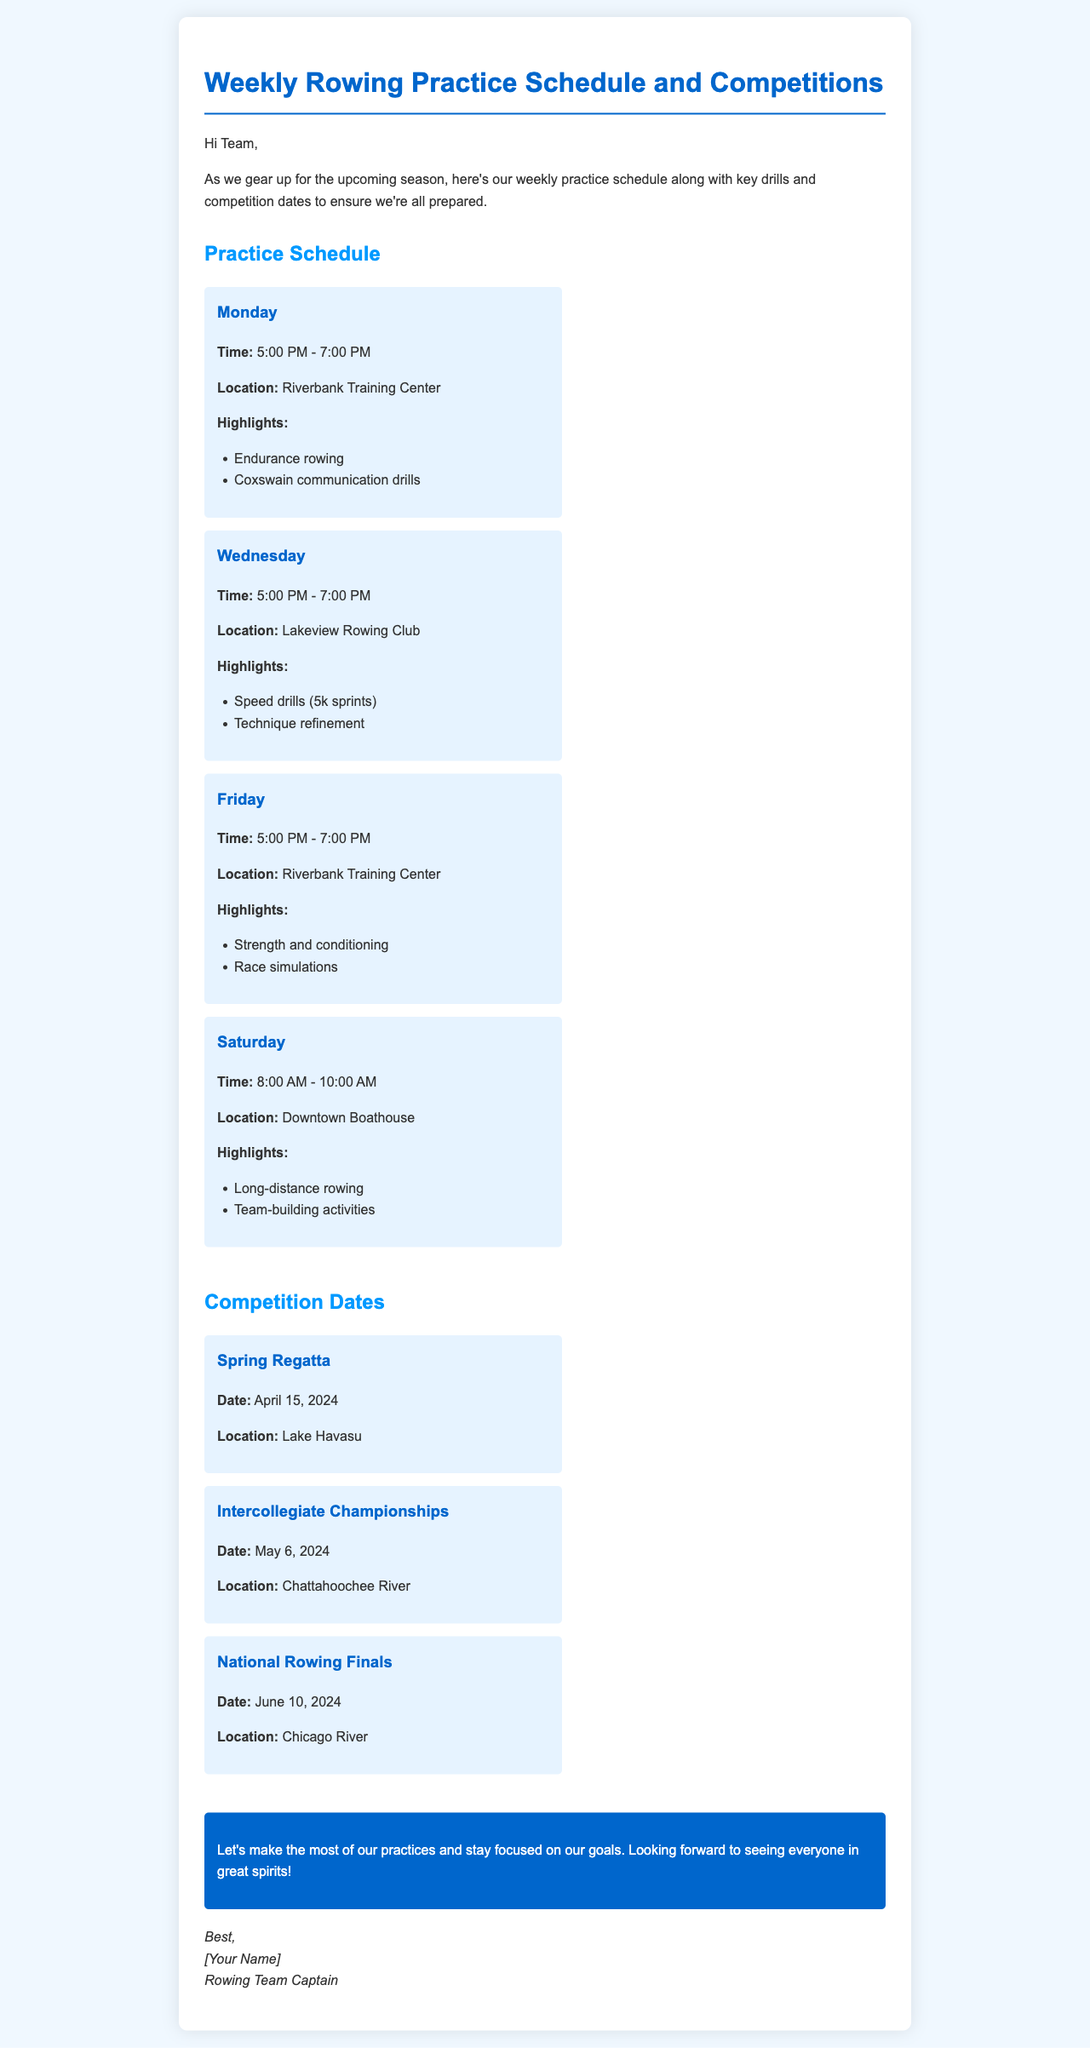What time does practice start on Monday? The schedule states that practice on Monday starts at 5:00 PM.
Answer: 5:00 PM Where will the Spring Regatta take place? The document lists Lake Havasu as the location for the Spring Regatta.
Answer: Lake Havasu What is the main focus on Friday's practice? The highlights for Friday's practice include strength and conditioning.
Answer: Strength and conditioning How many competitions are listed in the document? The document lists three competitions under the Competition Dates section.
Answer: Three What is the date of the National Rowing Finals? The document specifies that the National Rowing Finals will be on June 10, 2024.
Answer: June 10, 2024 What is the duration of Wednesday's practice? Wednesday's practice is scheduled for 2 hours, from 5:00 PM to 7:00 PM.
Answer: 2 hours What type of activities are included on Saturday? The highlights for Saturday's practice involve team-building activities.
Answer: Team-building activities Which day features speed drills? The Wednesday practice includes speed drills as part of its highlights.
Answer: Wednesday 